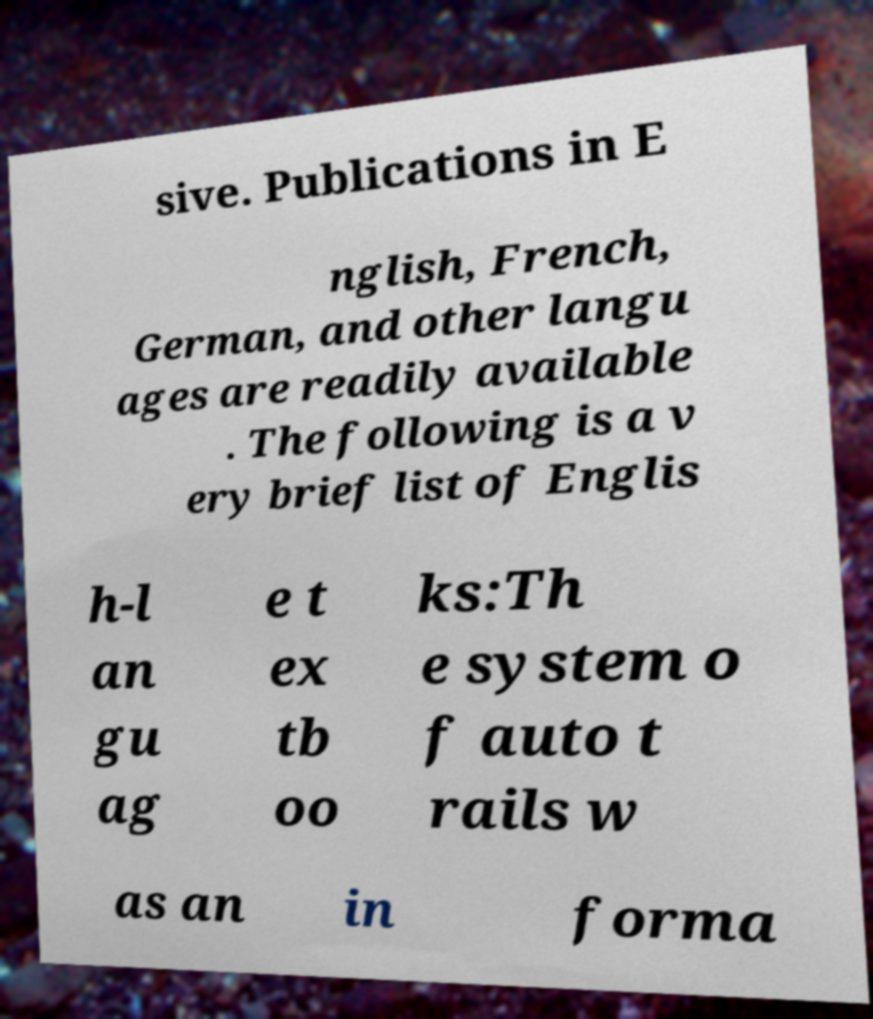Can you read and provide the text displayed in the image?This photo seems to have some interesting text. Can you extract and type it out for me? sive. Publications in E nglish, French, German, and other langu ages are readily available . The following is a v ery brief list of Englis h-l an gu ag e t ex tb oo ks:Th e system o f auto t rails w as an in forma 